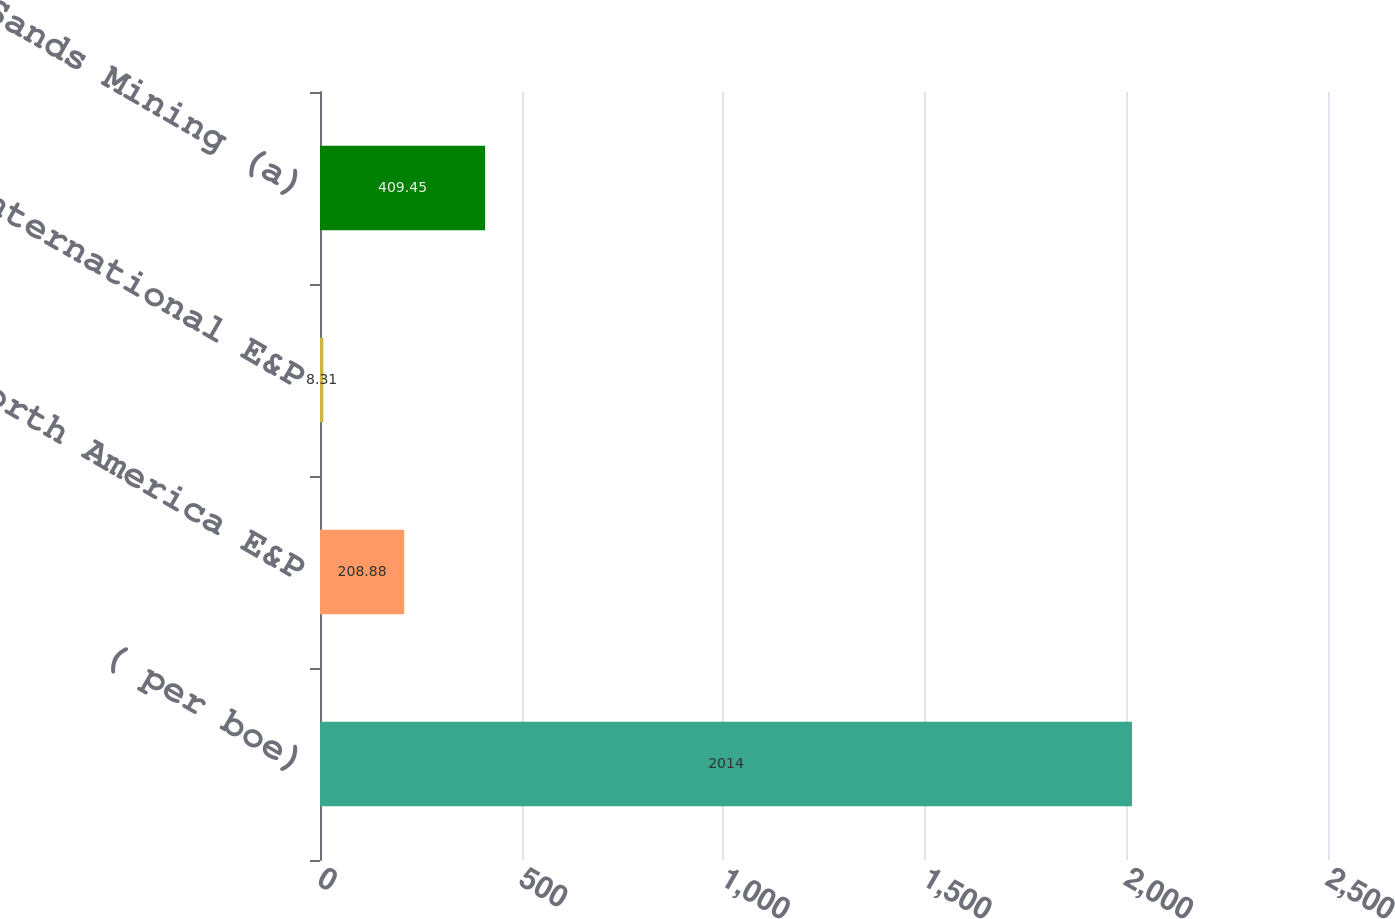Convert chart. <chart><loc_0><loc_0><loc_500><loc_500><bar_chart><fcel>( per boe)<fcel>North America E&P<fcel>International E&P<fcel>Oil Sands Mining (a)<nl><fcel>2014<fcel>208.88<fcel>8.31<fcel>409.45<nl></chart> 